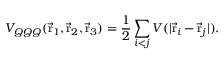<formula> <loc_0><loc_0><loc_500><loc_500>V _ { Q Q Q } ( \vec { r } _ { 1 } , \vec { r } _ { 2 } , \vec { r } _ { 3 } ) = { \frac { 1 } { 2 } } \sum _ { i < j } V ( | \vec { r } _ { i } - \vec { r } _ { j } | ) .</formula> 